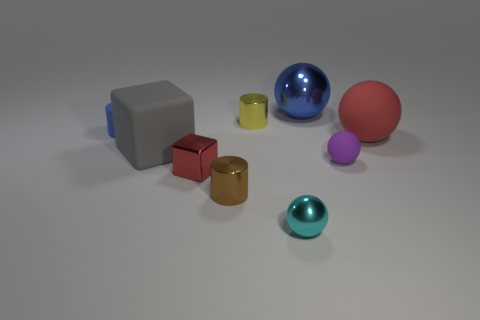Subtract all tiny cyan spheres. How many spheres are left? 3 Add 1 blue matte objects. How many objects exist? 10 Subtract 1 blocks. How many blocks are left? 1 Subtract all cyan balls. How many balls are left? 3 Subtract all spheres. How many objects are left? 5 Add 2 big matte objects. How many big matte objects are left? 4 Add 9 big gray matte things. How many big gray matte things exist? 10 Subtract 0 brown balls. How many objects are left? 9 Subtract all brown cubes. Subtract all brown cylinders. How many cubes are left? 2 Subtract all red cubes. Subtract all small cyan metallic objects. How many objects are left? 7 